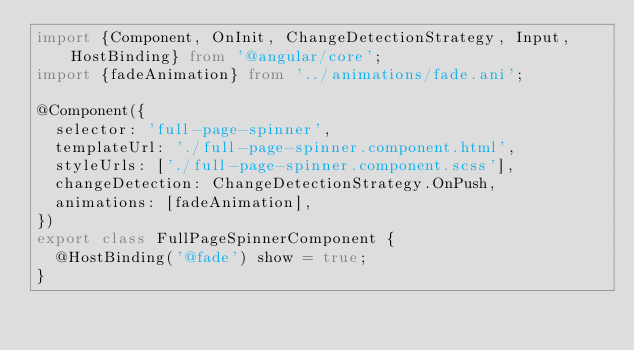<code> <loc_0><loc_0><loc_500><loc_500><_TypeScript_>import {Component, OnInit, ChangeDetectionStrategy, Input, HostBinding} from '@angular/core';
import {fadeAnimation} from '../animations/fade.ani';

@Component({
  selector: 'full-page-spinner',
  templateUrl: './full-page-spinner.component.html',
  styleUrls: ['./full-page-spinner.component.scss'],
  changeDetection: ChangeDetectionStrategy.OnPush,
  animations: [fadeAnimation],
})
export class FullPageSpinnerComponent {
  @HostBinding('@fade') show = true;
}
</code> 